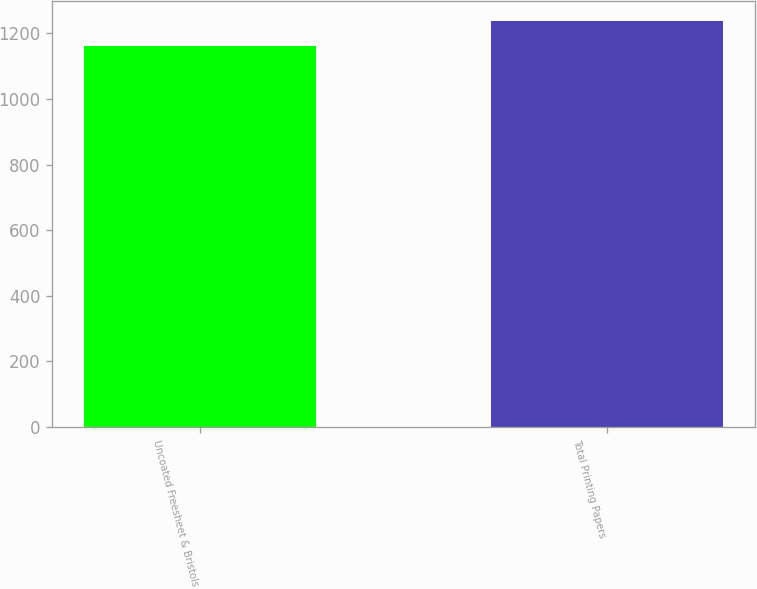Convert chart to OTSL. <chart><loc_0><loc_0><loc_500><loc_500><bar_chart><fcel>Uncoated Freesheet & Bristols<fcel>Total Printing Papers<nl><fcel>1162<fcel>1237<nl></chart> 